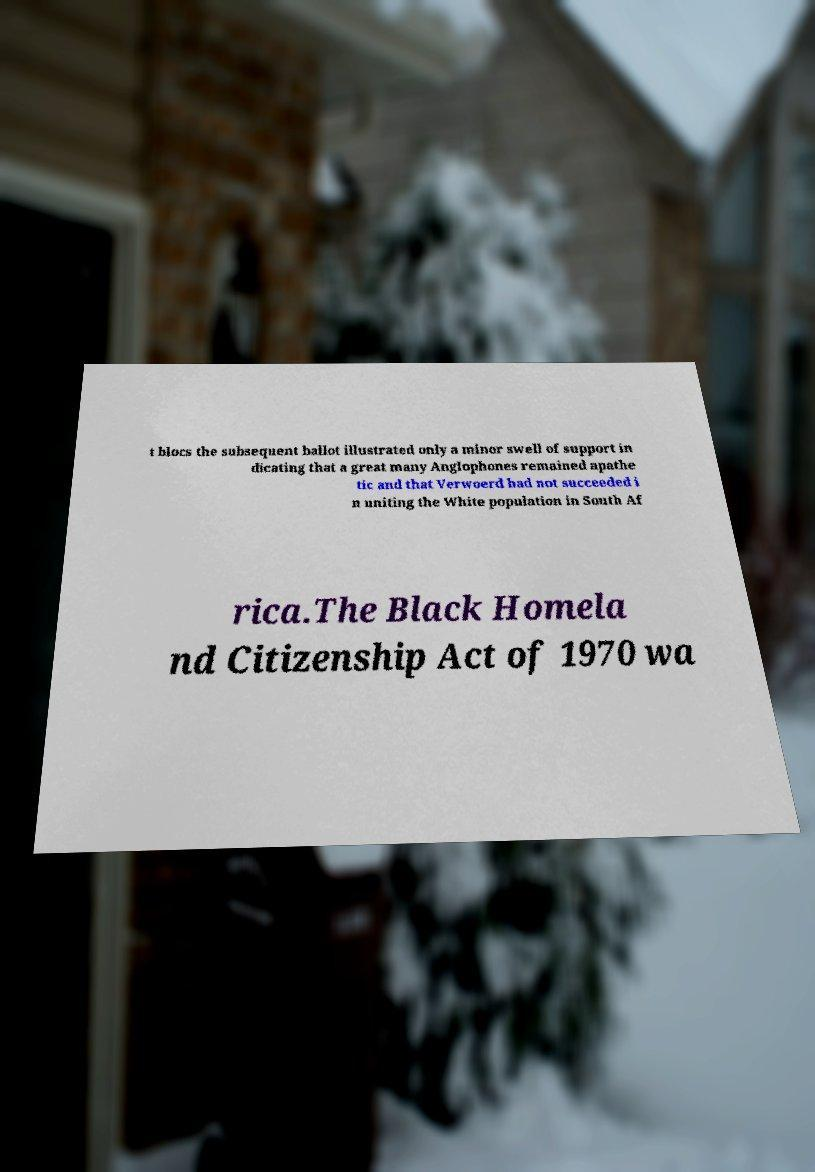I need the written content from this picture converted into text. Can you do that? t blocs the subsequent ballot illustrated only a minor swell of support in dicating that a great many Anglophones remained apathe tic and that Verwoerd had not succeeded i n uniting the White population in South Af rica.The Black Homela nd Citizenship Act of 1970 wa 